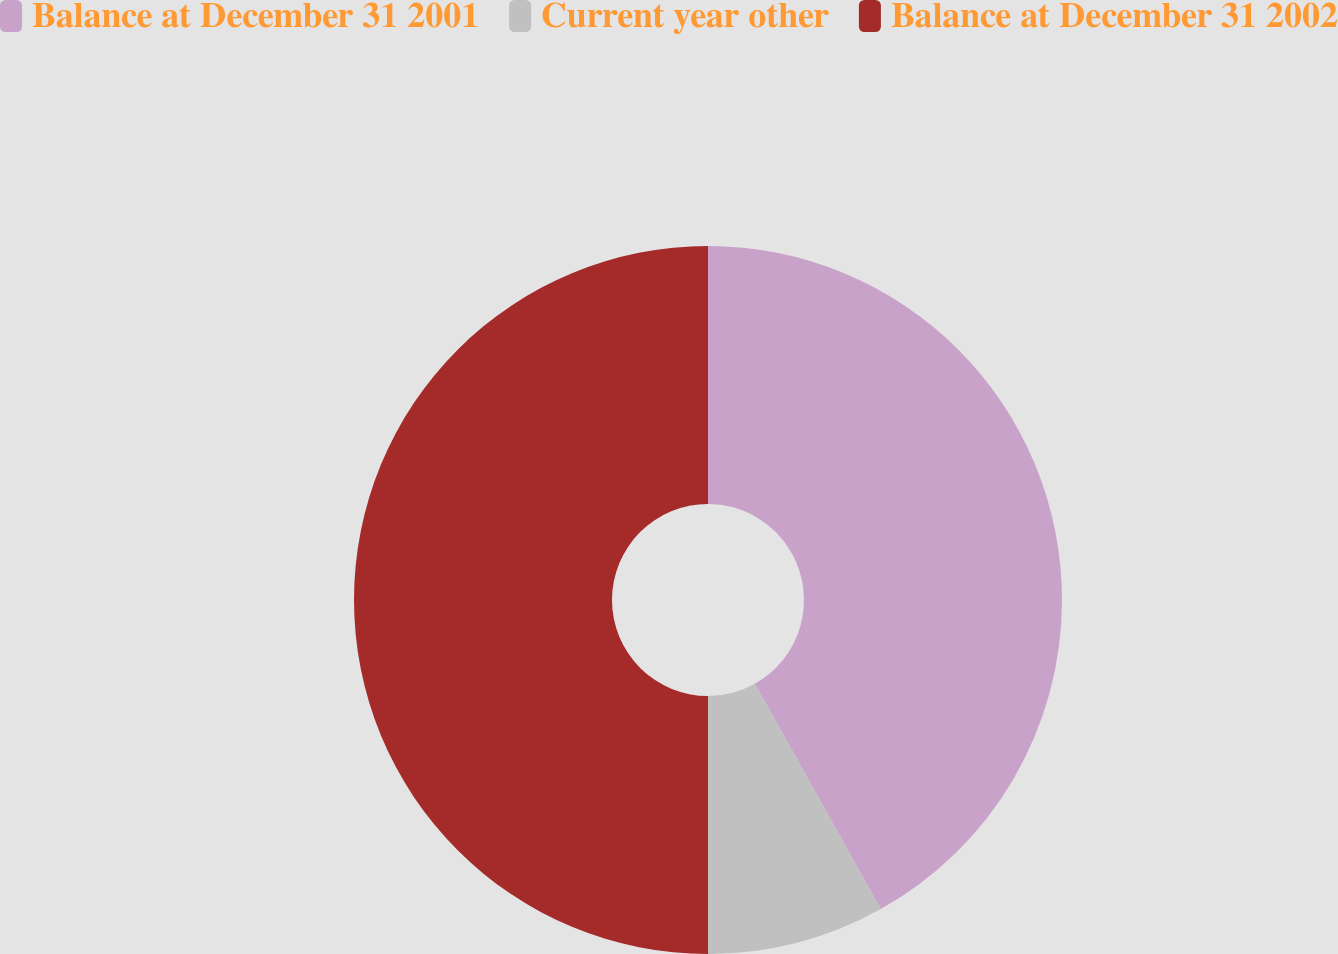Convert chart. <chart><loc_0><loc_0><loc_500><loc_500><pie_chart><fcel>Balance at December 31 2001<fcel>Current year other<fcel>Balance at December 31 2002<nl><fcel>41.89%<fcel>8.11%<fcel>50.0%<nl></chart> 